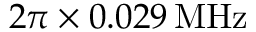Convert formula to latex. <formula><loc_0><loc_0><loc_500><loc_500>2 \pi \times 0 . 0 2 9 \, M H z</formula> 